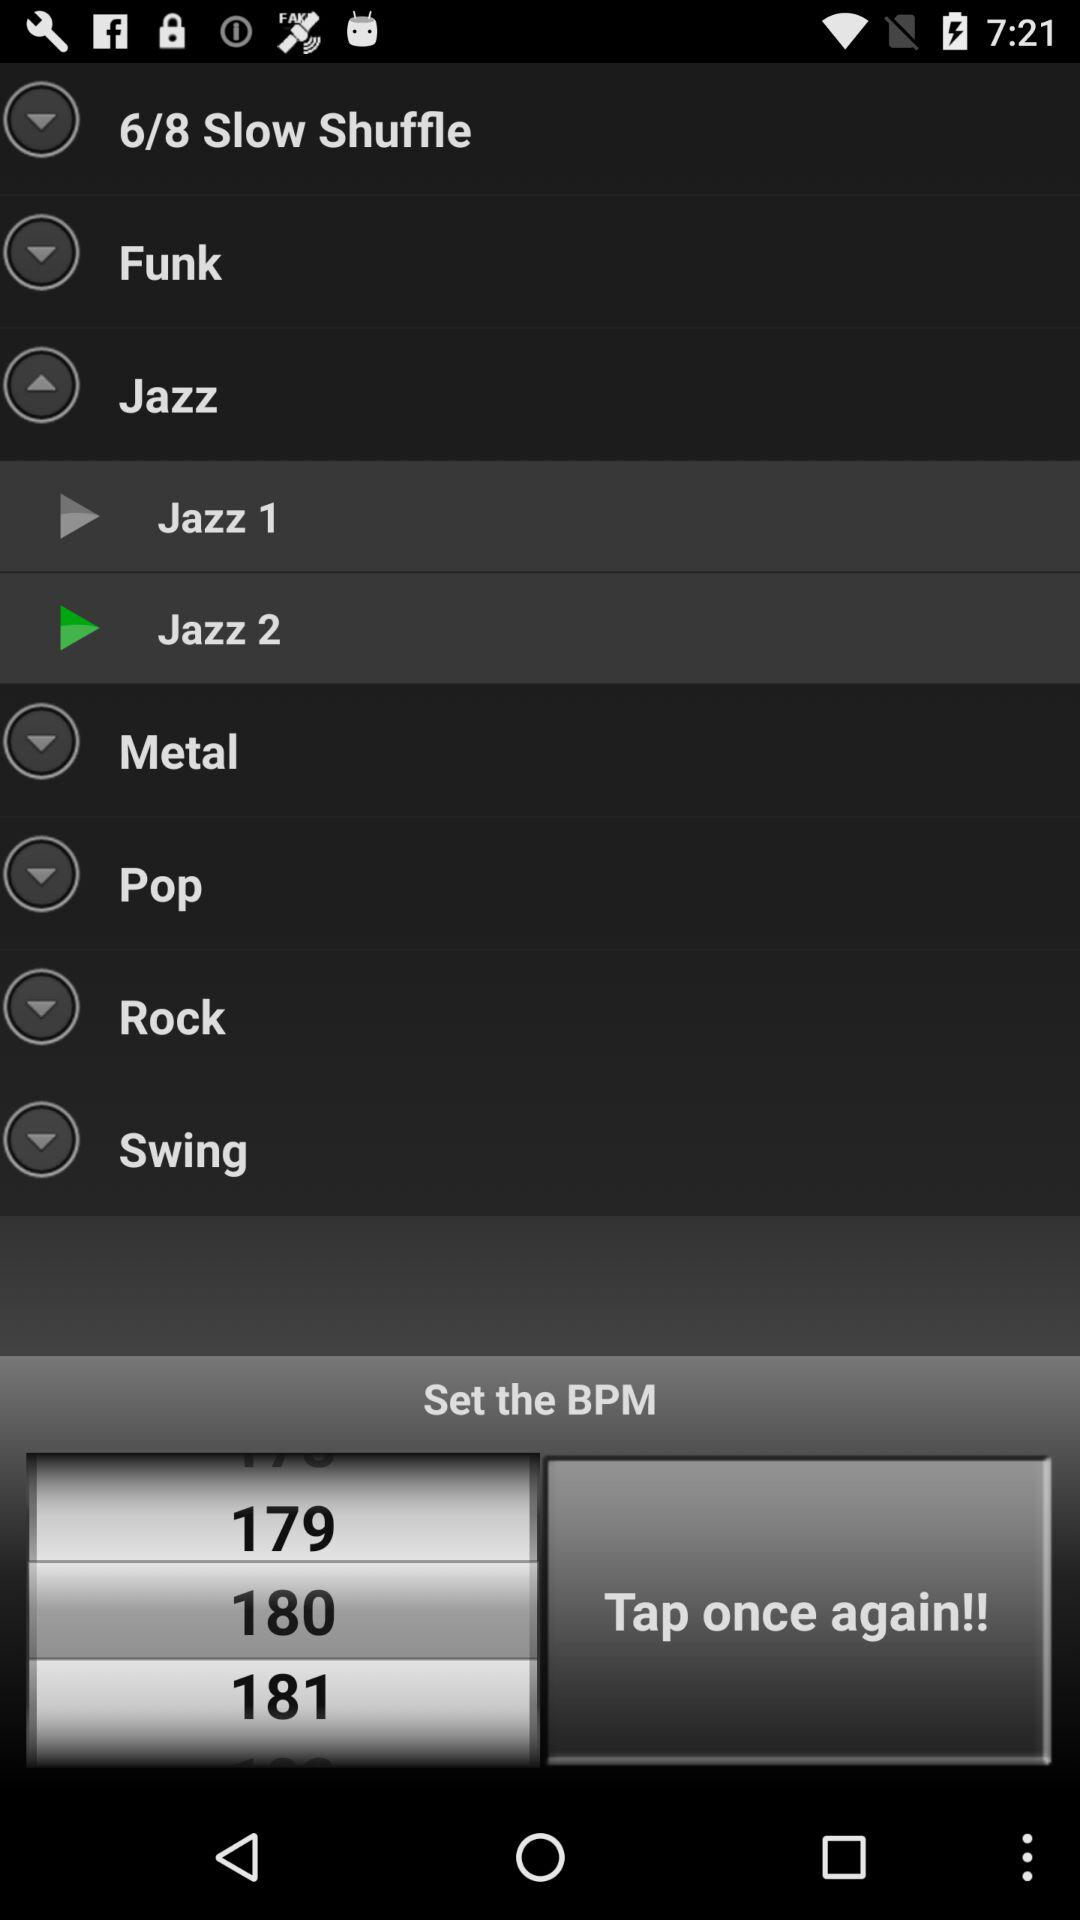What is the total number of slow shuffle? The total number of slow shuffle is 8. 